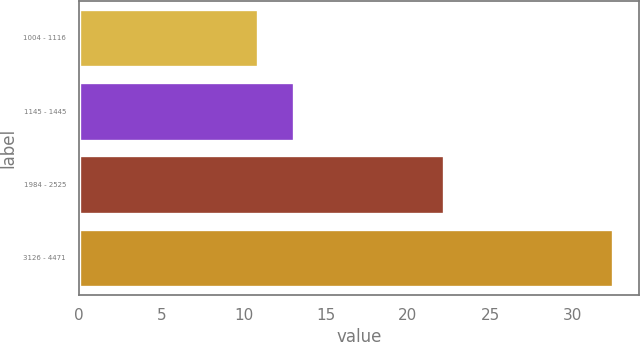Convert chart to OTSL. <chart><loc_0><loc_0><loc_500><loc_500><bar_chart><fcel>1004 - 1116<fcel>1145 - 1445<fcel>1984 - 2525<fcel>3126 - 4471<nl><fcel>10.88<fcel>13.04<fcel>22.17<fcel>32.46<nl></chart> 